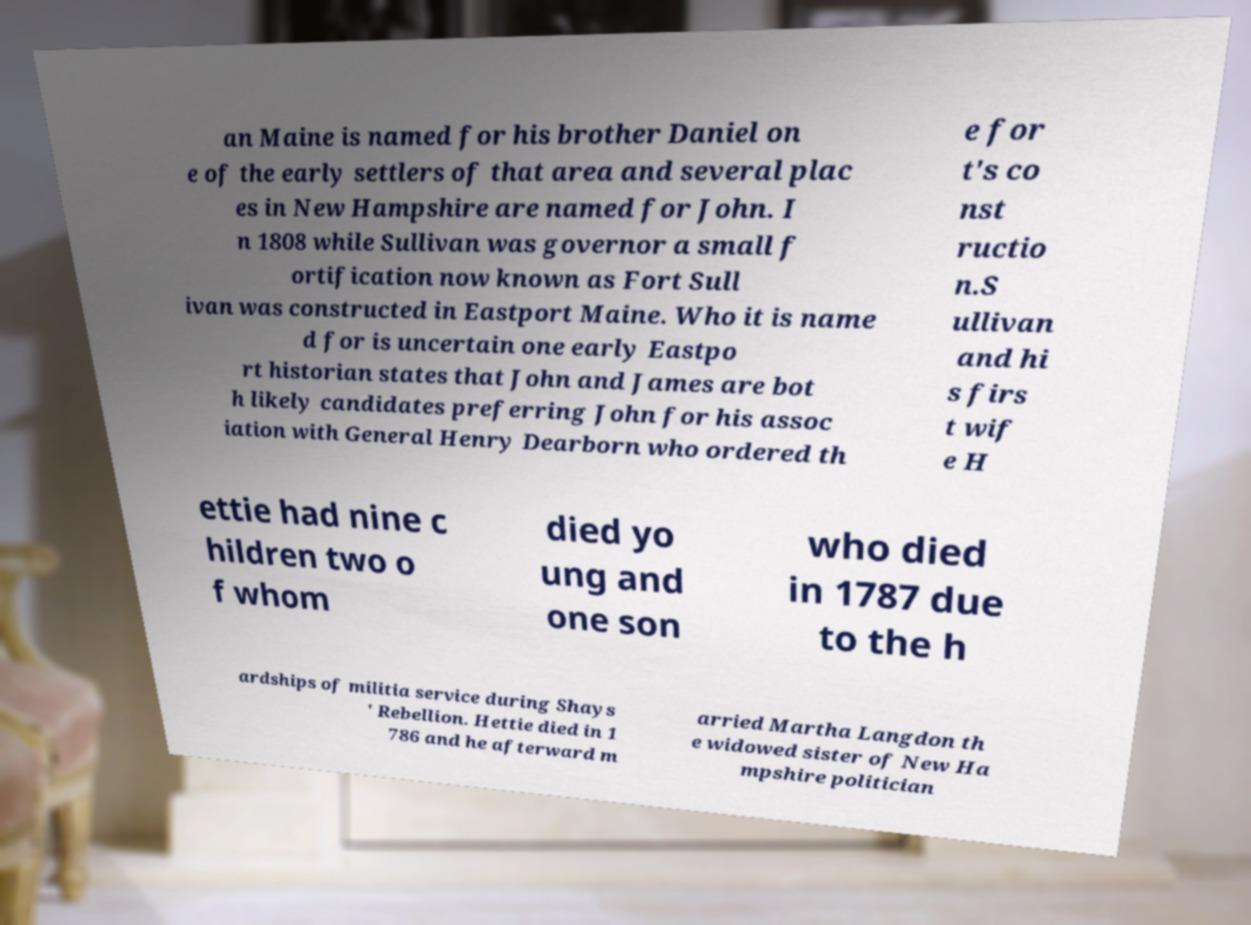Please identify and transcribe the text found in this image. an Maine is named for his brother Daniel on e of the early settlers of that area and several plac es in New Hampshire are named for John. I n 1808 while Sullivan was governor a small f ortification now known as Fort Sull ivan was constructed in Eastport Maine. Who it is name d for is uncertain one early Eastpo rt historian states that John and James are bot h likely candidates preferring John for his assoc iation with General Henry Dearborn who ordered th e for t's co nst ructio n.S ullivan and hi s firs t wif e H ettie had nine c hildren two o f whom died yo ung and one son who died in 1787 due to the h ardships of militia service during Shays ' Rebellion. Hettie died in 1 786 and he afterward m arried Martha Langdon th e widowed sister of New Ha mpshire politician 